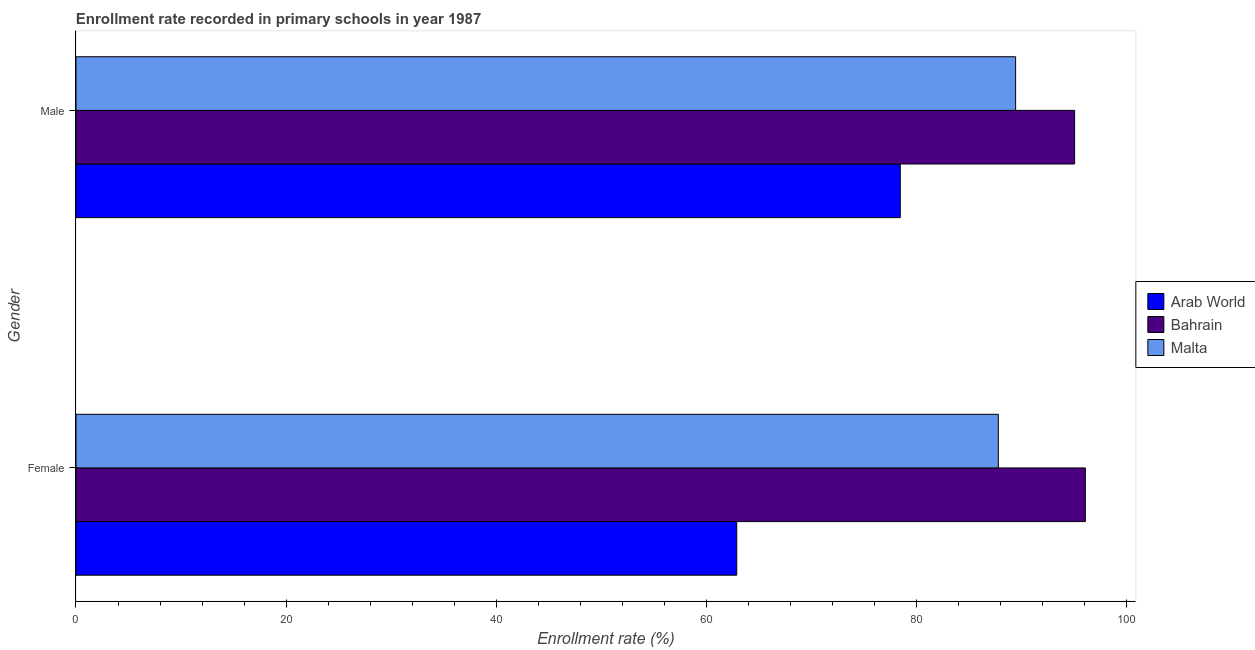How many different coloured bars are there?
Offer a terse response. 3. Are the number of bars per tick equal to the number of legend labels?
Provide a succinct answer. Yes. Are the number of bars on each tick of the Y-axis equal?
Provide a succinct answer. Yes. What is the label of the 2nd group of bars from the top?
Your response must be concise. Female. What is the enrollment rate of male students in Malta?
Make the answer very short. 89.44. Across all countries, what is the maximum enrollment rate of male students?
Keep it short and to the point. 95.06. Across all countries, what is the minimum enrollment rate of female students?
Ensure brevity in your answer.  62.89. In which country was the enrollment rate of female students maximum?
Provide a succinct answer. Bahrain. In which country was the enrollment rate of male students minimum?
Offer a terse response. Arab World. What is the total enrollment rate of female students in the graph?
Offer a terse response. 246.77. What is the difference between the enrollment rate of female students in Malta and that in Arab World?
Your answer should be compact. 24.9. What is the difference between the enrollment rate of male students in Arab World and the enrollment rate of female students in Bahrain?
Keep it short and to the point. -17.62. What is the average enrollment rate of male students per country?
Your response must be concise. 87.65. What is the difference between the enrollment rate of male students and enrollment rate of female students in Arab World?
Offer a terse response. 15.57. What is the ratio of the enrollment rate of male students in Bahrain to that in Arab World?
Your answer should be compact. 1.21. In how many countries, is the enrollment rate of female students greater than the average enrollment rate of female students taken over all countries?
Provide a succinct answer. 2. What does the 2nd bar from the top in Female represents?
Provide a short and direct response. Bahrain. What does the 3rd bar from the bottom in Male represents?
Ensure brevity in your answer.  Malta. Where does the legend appear in the graph?
Your answer should be very brief. Center right. What is the title of the graph?
Ensure brevity in your answer.  Enrollment rate recorded in primary schools in year 1987. What is the label or title of the X-axis?
Provide a succinct answer. Enrollment rate (%). What is the label or title of the Y-axis?
Your answer should be very brief. Gender. What is the Enrollment rate (%) in Arab World in Female?
Your answer should be compact. 62.89. What is the Enrollment rate (%) of Bahrain in Female?
Your answer should be compact. 96.08. What is the Enrollment rate (%) in Malta in Female?
Keep it short and to the point. 87.8. What is the Enrollment rate (%) of Arab World in Male?
Provide a succinct answer. 78.46. What is the Enrollment rate (%) of Bahrain in Male?
Your response must be concise. 95.06. What is the Enrollment rate (%) in Malta in Male?
Ensure brevity in your answer.  89.44. Across all Gender, what is the maximum Enrollment rate (%) of Arab World?
Give a very brief answer. 78.46. Across all Gender, what is the maximum Enrollment rate (%) in Bahrain?
Provide a short and direct response. 96.08. Across all Gender, what is the maximum Enrollment rate (%) of Malta?
Your answer should be very brief. 89.44. Across all Gender, what is the minimum Enrollment rate (%) in Arab World?
Make the answer very short. 62.89. Across all Gender, what is the minimum Enrollment rate (%) of Bahrain?
Offer a very short reply. 95.06. Across all Gender, what is the minimum Enrollment rate (%) of Malta?
Make the answer very short. 87.8. What is the total Enrollment rate (%) of Arab World in the graph?
Give a very brief answer. 141.36. What is the total Enrollment rate (%) in Bahrain in the graph?
Provide a short and direct response. 191.14. What is the total Enrollment rate (%) of Malta in the graph?
Make the answer very short. 177.24. What is the difference between the Enrollment rate (%) in Arab World in Female and that in Male?
Offer a very short reply. -15.57. What is the difference between the Enrollment rate (%) in Bahrain in Female and that in Male?
Your answer should be very brief. 1.02. What is the difference between the Enrollment rate (%) in Malta in Female and that in Male?
Your answer should be compact. -1.65. What is the difference between the Enrollment rate (%) in Arab World in Female and the Enrollment rate (%) in Bahrain in Male?
Keep it short and to the point. -32.16. What is the difference between the Enrollment rate (%) in Arab World in Female and the Enrollment rate (%) in Malta in Male?
Make the answer very short. -26.55. What is the difference between the Enrollment rate (%) of Bahrain in Female and the Enrollment rate (%) of Malta in Male?
Ensure brevity in your answer.  6.64. What is the average Enrollment rate (%) of Arab World per Gender?
Offer a very short reply. 70.68. What is the average Enrollment rate (%) in Bahrain per Gender?
Ensure brevity in your answer.  95.57. What is the average Enrollment rate (%) in Malta per Gender?
Give a very brief answer. 88.62. What is the difference between the Enrollment rate (%) in Arab World and Enrollment rate (%) in Bahrain in Female?
Offer a terse response. -33.18. What is the difference between the Enrollment rate (%) in Arab World and Enrollment rate (%) in Malta in Female?
Your answer should be very brief. -24.9. What is the difference between the Enrollment rate (%) in Bahrain and Enrollment rate (%) in Malta in Female?
Keep it short and to the point. 8.28. What is the difference between the Enrollment rate (%) in Arab World and Enrollment rate (%) in Bahrain in Male?
Ensure brevity in your answer.  -16.6. What is the difference between the Enrollment rate (%) of Arab World and Enrollment rate (%) of Malta in Male?
Offer a terse response. -10.98. What is the difference between the Enrollment rate (%) in Bahrain and Enrollment rate (%) in Malta in Male?
Your response must be concise. 5.62. What is the ratio of the Enrollment rate (%) of Arab World in Female to that in Male?
Ensure brevity in your answer.  0.8. What is the ratio of the Enrollment rate (%) of Bahrain in Female to that in Male?
Give a very brief answer. 1.01. What is the ratio of the Enrollment rate (%) in Malta in Female to that in Male?
Provide a short and direct response. 0.98. What is the difference between the highest and the second highest Enrollment rate (%) of Arab World?
Keep it short and to the point. 15.57. What is the difference between the highest and the second highest Enrollment rate (%) of Bahrain?
Your answer should be compact. 1.02. What is the difference between the highest and the second highest Enrollment rate (%) of Malta?
Provide a short and direct response. 1.65. What is the difference between the highest and the lowest Enrollment rate (%) in Arab World?
Offer a very short reply. 15.57. What is the difference between the highest and the lowest Enrollment rate (%) of Bahrain?
Ensure brevity in your answer.  1.02. What is the difference between the highest and the lowest Enrollment rate (%) in Malta?
Your response must be concise. 1.65. 